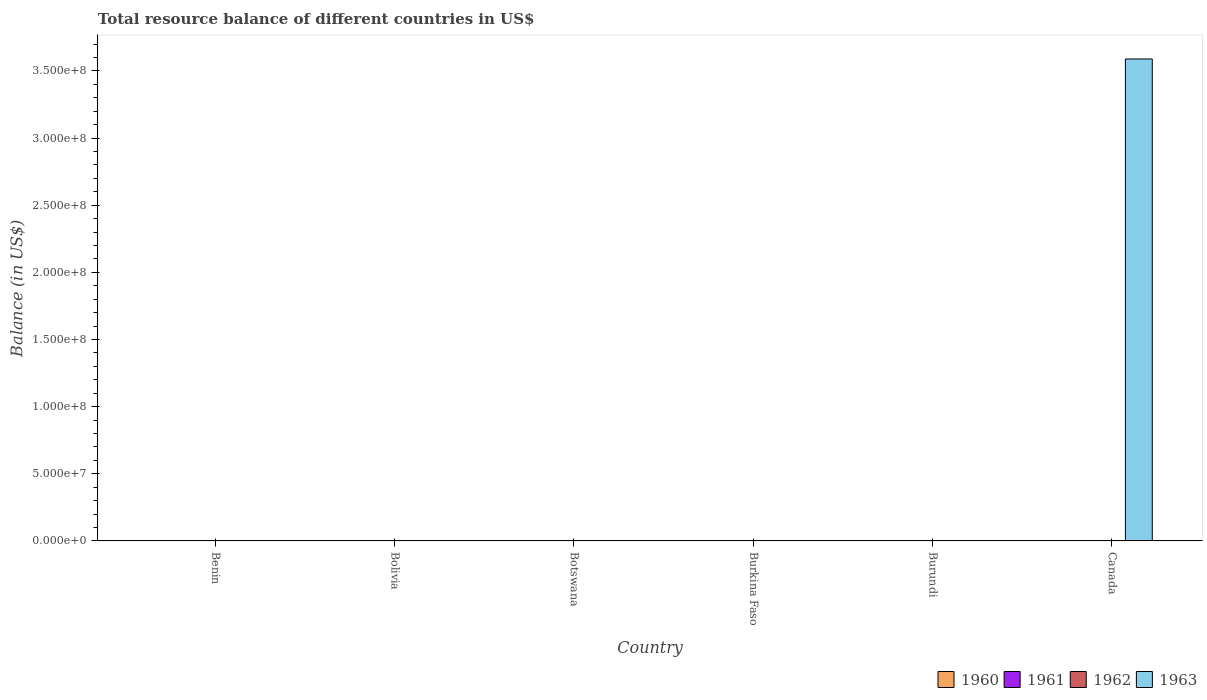How many different coloured bars are there?
Offer a very short reply. 1. Are the number of bars per tick equal to the number of legend labels?
Give a very brief answer. No. Are the number of bars on each tick of the X-axis equal?
Ensure brevity in your answer.  No. What is the total resource balance in 1961 in Burundi?
Your answer should be compact. 0. Across all countries, what is the maximum total resource balance in 1963?
Provide a short and direct response. 3.59e+08. Across all countries, what is the minimum total resource balance in 1963?
Offer a terse response. 0. In which country was the total resource balance in 1963 maximum?
Provide a succinct answer. Canada. What is the total total resource balance in 1963 in the graph?
Your answer should be compact. 3.59e+08. What is the difference between the total resource balance in 1963 in Canada and the total resource balance in 1960 in Burkina Faso?
Your response must be concise. 3.59e+08. What is the average total resource balance in 1962 per country?
Your answer should be very brief. 0. What is the difference between the highest and the lowest total resource balance in 1963?
Provide a succinct answer. 3.59e+08. In how many countries, is the total resource balance in 1963 greater than the average total resource balance in 1963 taken over all countries?
Provide a succinct answer. 1. How many bars are there?
Offer a terse response. 1. Does the graph contain any zero values?
Give a very brief answer. Yes. Does the graph contain grids?
Your answer should be compact. No. Where does the legend appear in the graph?
Give a very brief answer. Bottom right. How many legend labels are there?
Make the answer very short. 4. How are the legend labels stacked?
Provide a succinct answer. Horizontal. What is the title of the graph?
Your response must be concise. Total resource balance of different countries in US$. Does "1976" appear as one of the legend labels in the graph?
Your answer should be compact. No. What is the label or title of the Y-axis?
Provide a short and direct response. Balance (in US$). What is the Balance (in US$) in 1961 in Benin?
Make the answer very short. 0. What is the Balance (in US$) of 1961 in Bolivia?
Your answer should be very brief. 0. What is the Balance (in US$) of 1962 in Bolivia?
Offer a terse response. 0. What is the Balance (in US$) in 1963 in Bolivia?
Provide a succinct answer. 0. What is the Balance (in US$) in 1960 in Botswana?
Your response must be concise. 0. What is the Balance (in US$) of 1961 in Botswana?
Provide a short and direct response. 0. What is the Balance (in US$) in 1962 in Botswana?
Ensure brevity in your answer.  0. What is the Balance (in US$) of 1963 in Burkina Faso?
Provide a succinct answer. 0. What is the Balance (in US$) in 1963 in Burundi?
Offer a very short reply. 0. What is the Balance (in US$) in 1963 in Canada?
Your answer should be very brief. 3.59e+08. Across all countries, what is the maximum Balance (in US$) of 1963?
Offer a terse response. 3.59e+08. Across all countries, what is the minimum Balance (in US$) of 1963?
Offer a terse response. 0. What is the total Balance (in US$) in 1960 in the graph?
Provide a succinct answer. 0. What is the total Balance (in US$) of 1962 in the graph?
Offer a terse response. 0. What is the total Balance (in US$) in 1963 in the graph?
Provide a succinct answer. 3.59e+08. What is the average Balance (in US$) of 1963 per country?
Ensure brevity in your answer.  5.98e+07. What is the difference between the highest and the lowest Balance (in US$) of 1963?
Your answer should be compact. 3.59e+08. 